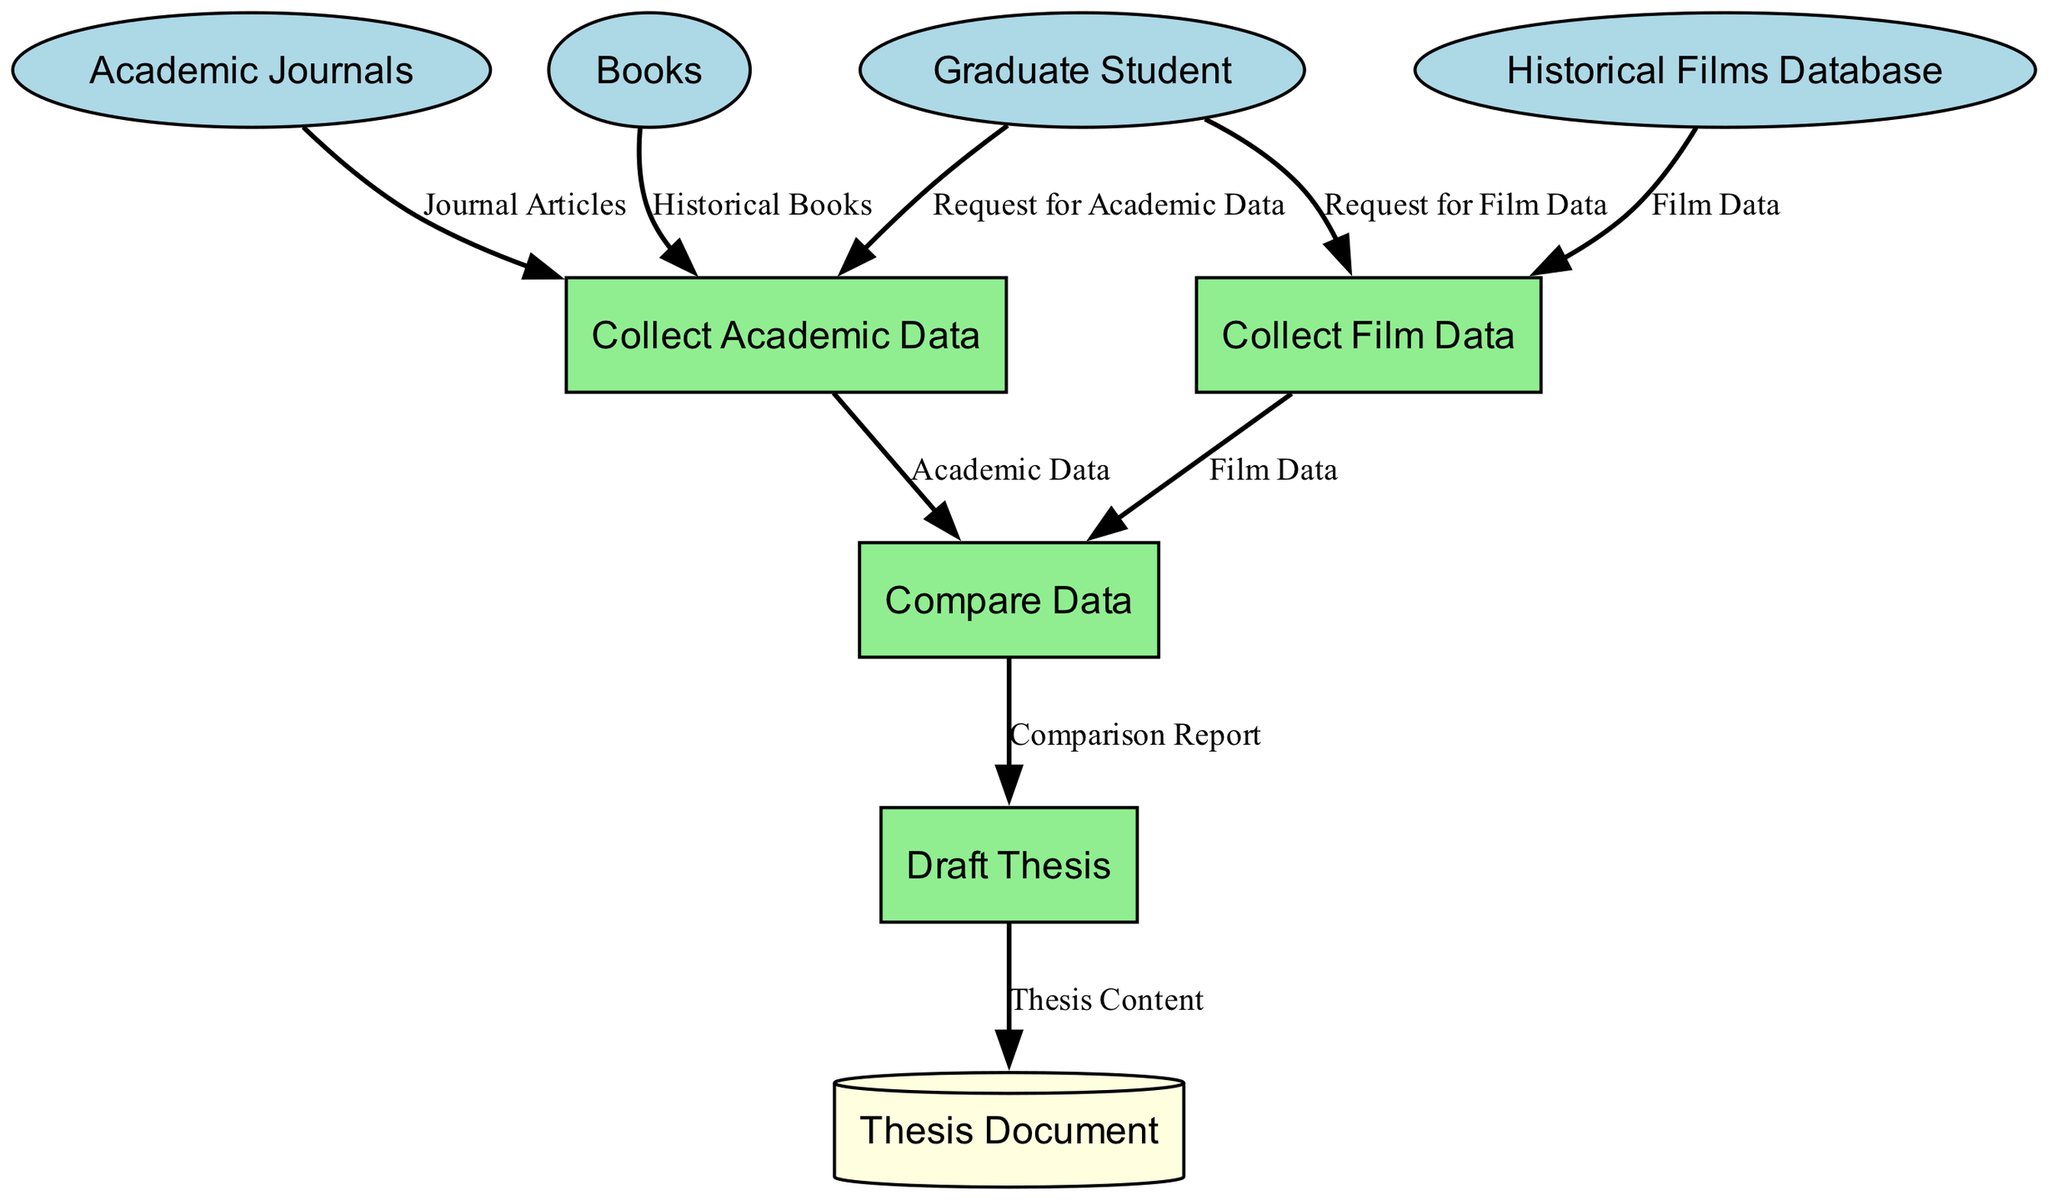What external entities are involved in this diagram? The diagram includes three external entities: Graduate Student, Historical Films Database, Academic Journals, and Books. I identify them as all entities that provide inputs or receive outputs from the processes.
Answer: Graduate Student, Historical Films Database, Academic Journals, Books How many processes are in the diagram? The diagram lists four processes: Collect Film Data, Collect Academic Data, Compare Data, and Draft Thesis. To determine this, I count the processes displayed, which are the actions undertaken in the data flow.
Answer: Four What is the output of the "Collect Film Data" process? The output of the "Collect Film Data" process is "Film Data." This is stated directly as the result of that process in the diagram.
Answer: Film Data What is the input for the "Compare Data" process? The "Compare Data" process takes two inputs: "Film Data" and "Academic Data." I find this by checking which outputs from the prior processes are directed to "Compare Data."
Answer: Film Data, Academic Data What entity sends a request for academic data? The entity that sends a request for academic data is the Graduate Student. This can be determined by looking at the flow of information originating from the Graduate Student directing towards the "Collect Academic Data" process.
Answer: Graduate Student What document is generated after the "Draft Thesis" process? The document generated after the "Draft Thesis" process is called "Thesis Document." I arrive at this conclusion by tracing the final output from the last process in the diagram.
Answer: Thesis Document Which data sources are used to collect academic data? The sources used to collect academic data are Academic Journals and Books. I identify these by examining the inputs for the "Collect Academic Data" process listed in the diagram.
Answer: Academic Journals, Books What is the relationship between "Compare Data" and "Draft Thesis"? The relationship is that "Compare Data" provides the input "Comparison Report" to "Draft Thesis." This shows a direct flow where one process feeds into the next.
Answer: Comparison Report How many data flows are in the diagram? There are eight data flows in the diagram, which are the arrows showing the movement of data between entities and processes. I count each connection to determine this number.
Answer: Eight 